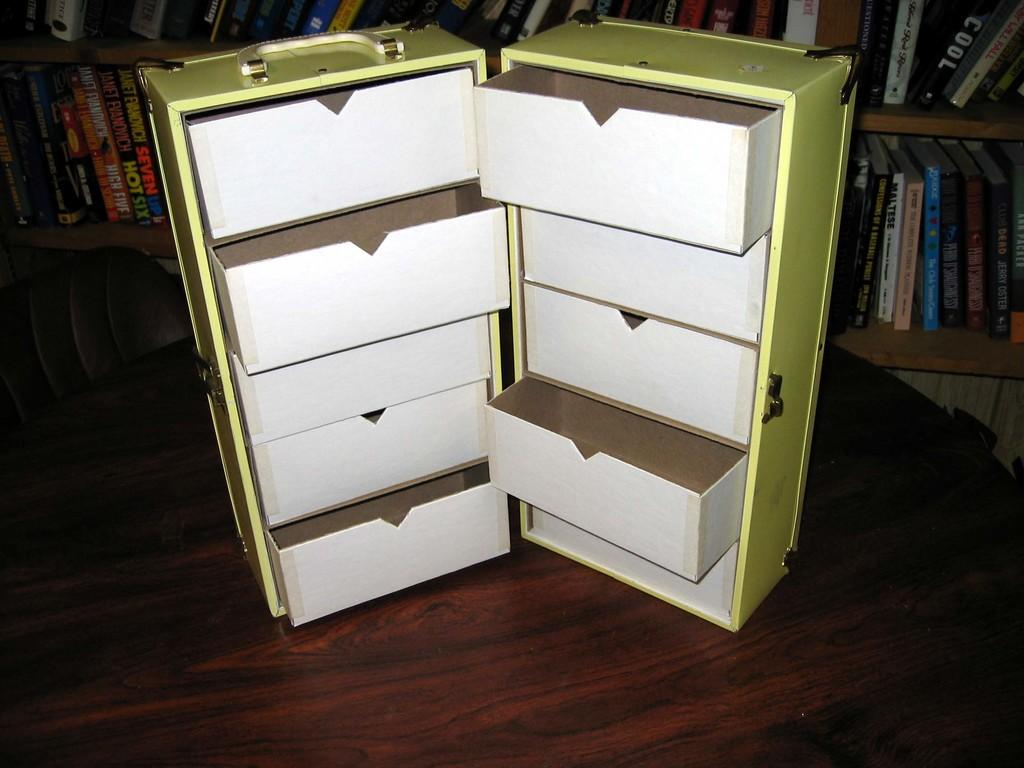What is on the table in the image? There is a box with racks on a table. What can be seen in the background of the image? There is a chair and books in book shelves in the background. What time of day is it in the image, based on the presence of a bird? There is no bird present in the image, so we cannot determine the time of day based on that. 